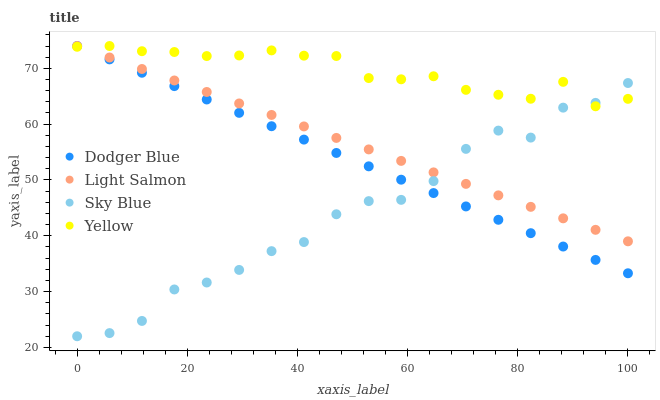Does Sky Blue have the minimum area under the curve?
Answer yes or no. Yes. Does Yellow have the maximum area under the curve?
Answer yes or no. Yes. Does Light Salmon have the minimum area under the curve?
Answer yes or no. No. Does Light Salmon have the maximum area under the curve?
Answer yes or no. No. Is Light Salmon the smoothest?
Answer yes or no. Yes. Is Sky Blue the roughest?
Answer yes or no. Yes. Is Dodger Blue the smoothest?
Answer yes or no. No. Is Dodger Blue the roughest?
Answer yes or no. No. Does Sky Blue have the lowest value?
Answer yes or no. Yes. Does Light Salmon have the lowest value?
Answer yes or no. No. Does Yellow have the highest value?
Answer yes or no. Yes. Does Sky Blue intersect Light Salmon?
Answer yes or no. Yes. Is Sky Blue less than Light Salmon?
Answer yes or no. No. Is Sky Blue greater than Light Salmon?
Answer yes or no. No. 